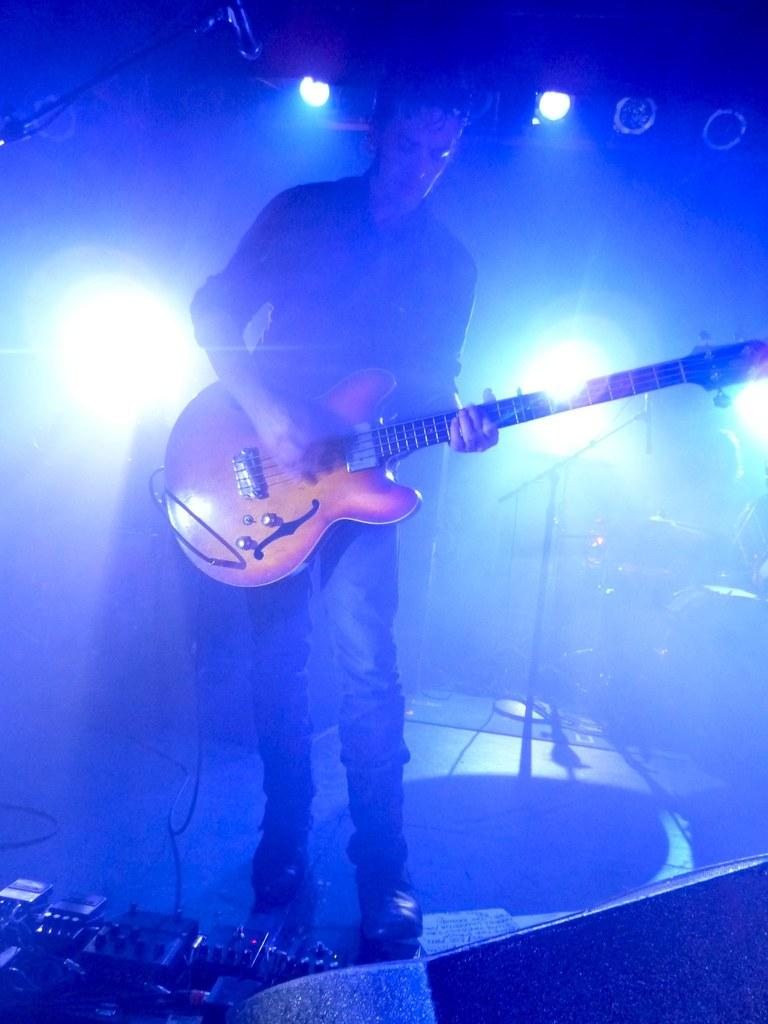What is the person in the image doing? The person is playing a guitar. What can be seen in the background of the image? There are lights visible in the background of the image. What type of dress is the person wearing in the image? The person is not wearing a dress in the image; they are wearing clothing suitable for playing the guitar. 